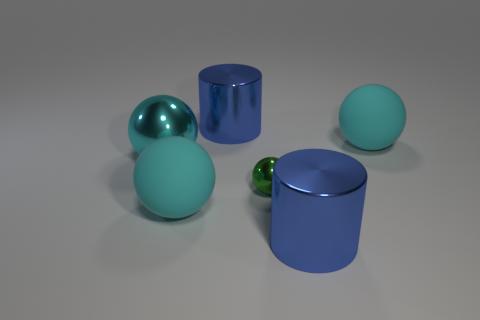Subtract all yellow cylinders. How many cyan spheres are left? 3 Subtract 1 spheres. How many spheres are left? 3 Subtract all big metallic spheres. How many spheres are left? 3 Subtract all green spheres. How many spheres are left? 3 Add 1 green shiny cylinders. How many objects exist? 7 Subtract all purple balls. Subtract all green cubes. How many balls are left? 4 Subtract all balls. How many objects are left? 2 Add 4 big spheres. How many big spheres exist? 7 Subtract 0 brown cylinders. How many objects are left? 6 Subtract all spheres. Subtract all purple metallic balls. How many objects are left? 2 